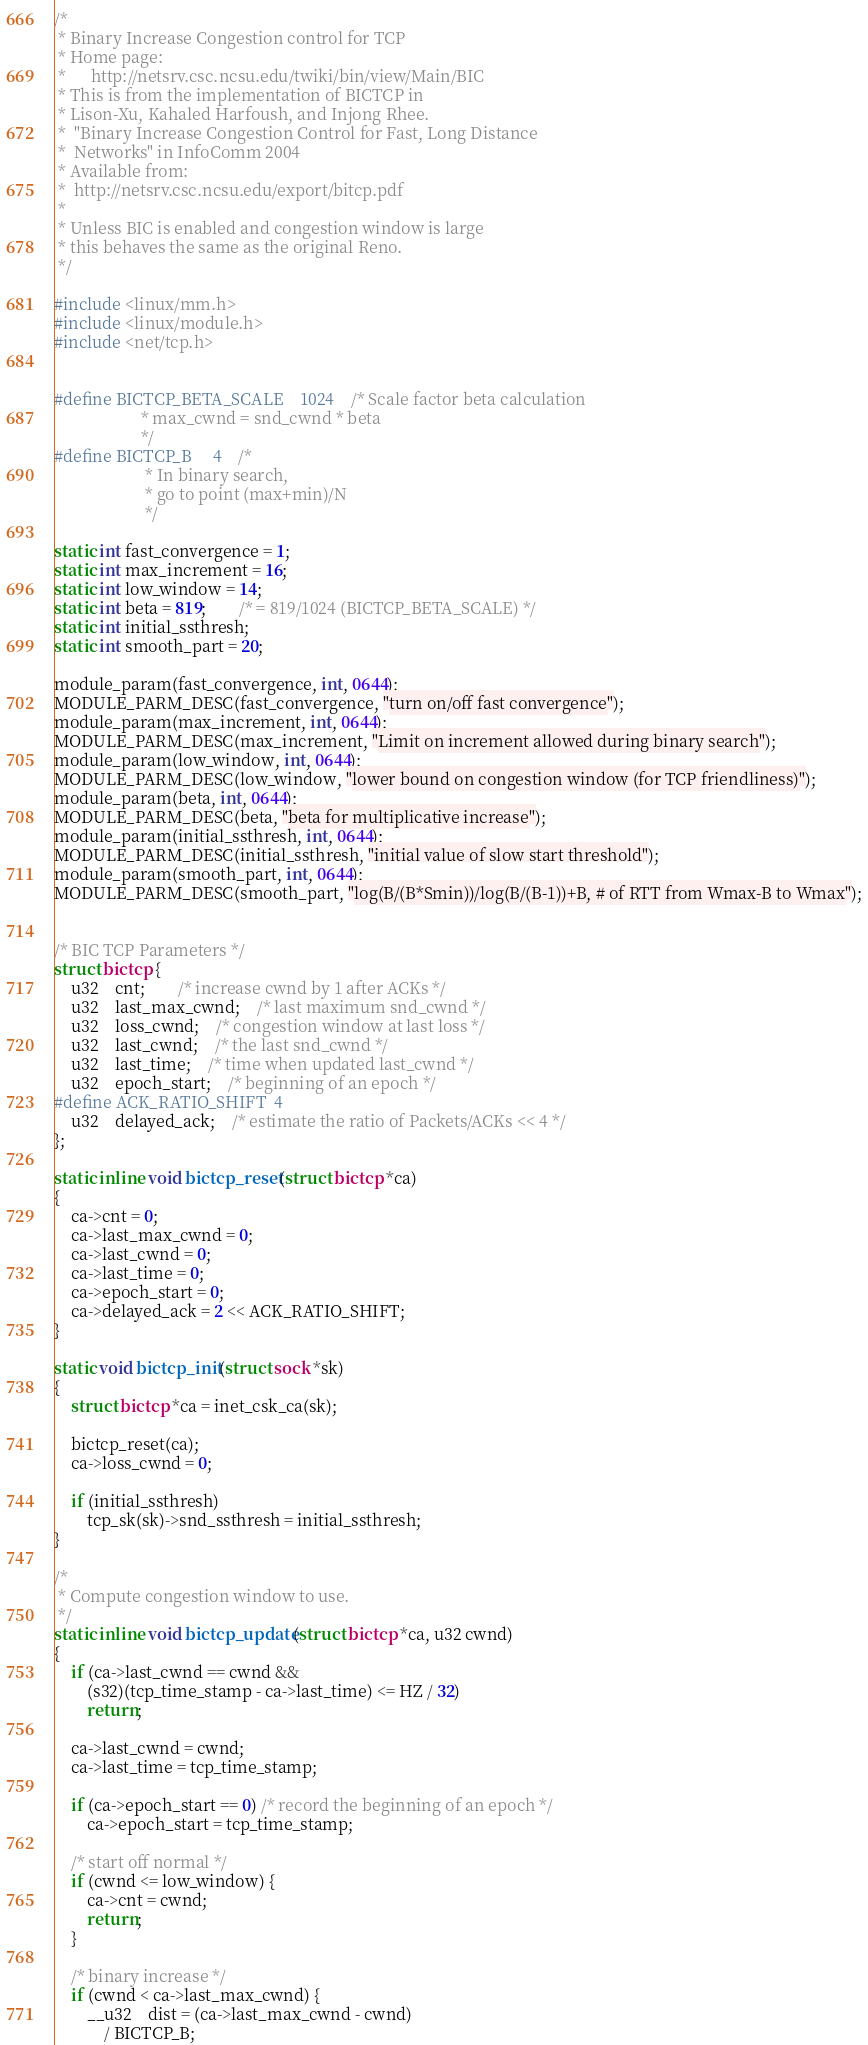<code> <loc_0><loc_0><loc_500><loc_500><_C_>/*
 * Binary Increase Congestion control for TCP
 * Home page:
 *      http://netsrv.csc.ncsu.edu/twiki/bin/view/Main/BIC
 * This is from the implementation of BICTCP in
 * Lison-Xu, Kahaled Harfoush, and Injong Rhee.
 *  "Binary Increase Congestion Control for Fast, Long Distance
 *  Networks" in InfoComm 2004
 * Available from:
 *  http://netsrv.csc.ncsu.edu/export/bitcp.pdf
 *
 * Unless BIC is enabled and congestion window is large
 * this behaves the same as the original Reno.
 */

#include <linux/mm.h>
#include <linux/module.h>
#include <net/tcp.h>


#define BICTCP_BETA_SCALE    1024	/* Scale factor beta calculation
					 * max_cwnd = snd_cwnd * beta
					 */
#define BICTCP_B		4	 /*
					  * In binary search,
					  * go to point (max+min)/N
					  */

static int fast_convergence = 1;
static int max_increment = 16;
static int low_window = 14;
static int beta = 819;		/* = 819/1024 (BICTCP_BETA_SCALE) */
static int initial_ssthresh;
static int smooth_part = 20;

module_param(fast_convergence, int, 0644);
MODULE_PARM_DESC(fast_convergence, "turn on/off fast convergence");
module_param(max_increment, int, 0644);
MODULE_PARM_DESC(max_increment, "Limit on increment allowed during binary search");
module_param(low_window, int, 0644);
MODULE_PARM_DESC(low_window, "lower bound on congestion window (for TCP friendliness)");
module_param(beta, int, 0644);
MODULE_PARM_DESC(beta, "beta for multiplicative increase");
module_param(initial_ssthresh, int, 0644);
MODULE_PARM_DESC(initial_ssthresh, "initial value of slow start threshold");
module_param(smooth_part, int, 0644);
MODULE_PARM_DESC(smooth_part, "log(B/(B*Smin))/log(B/(B-1))+B, # of RTT from Wmax-B to Wmax");


/* BIC TCP Parameters */
struct bictcp {
	u32	cnt;		/* increase cwnd by 1 after ACKs */
	u32 	last_max_cwnd;	/* last maximum snd_cwnd */
	u32	loss_cwnd;	/* congestion window at last loss */
	u32	last_cwnd;	/* the last snd_cwnd */
	u32	last_time;	/* time when updated last_cwnd */
	u32	epoch_start;	/* beginning of an epoch */
#define ACK_RATIO_SHIFT	4
	u32	delayed_ack;	/* estimate the ratio of Packets/ACKs << 4 */
};

static inline void bictcp_reset(struct bictcp *ca)
{
	ca->cnt = 0;
	ca->last_max_cwnd = 0;
	ca->last_cwnd = 0;
	ca->last_time = 0;
	ca->epoch_start = 0;
	ca->delayed_ack = 2 << ACK_RATIO_SHIFT;
}

static void bictcp_init(struct sock *sk)
{
	struct bictcp *ca = inet_csk_ca(sk);

	bictcp_reset(ca);
	ca->loss_cwnd = 0;

	if (initial_ssthresh)
		tcp_sk(sk)->snd_ssthresh = initial_ssthresh;
}

/*
 * Compute congestion window to use.
 */
static inline void bictcp_update(struct bictcp *ca, u32 cwnd)
{
	if (ca->last_cwnd == cwnd &&
	    (s32)(tcp_time_stamp - ca->last_time) <= HZ / 32)
		return;

	ca->last_cwnd = cwnd;
	ca->last_time = tcp_time_stamp;

	if (ca->epoch_start == 0) /* record the beginning of an epoch */
		ca->epoch_start = tcp_time_stamp;

	/* start off normal */
	if (cwnd <= low_window) {
		ca->cnt = cwnd;
		return;
	}

	/* binary increase */
	if (cwnd < ca->last_max_cwnd) {
		__u32 	dist = (ca->last_max_cwnd - cwnd)
			/ BICTCP_B;
</code> 